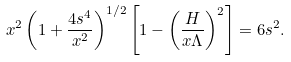<formula> <loc_0><loc_0><loc_500><loc_500>x ^ { 2 } \left ( 1 + \frac { 4 s ^ { 4 } } { x ^ { 2 } } \right ) ^ { 1 / 2 } \left [ 1 - \left ( \frac { H } { x \Lambda } \right ) ^ { 2 } \right ] = 6 s ^ { 2 } .</formula> 